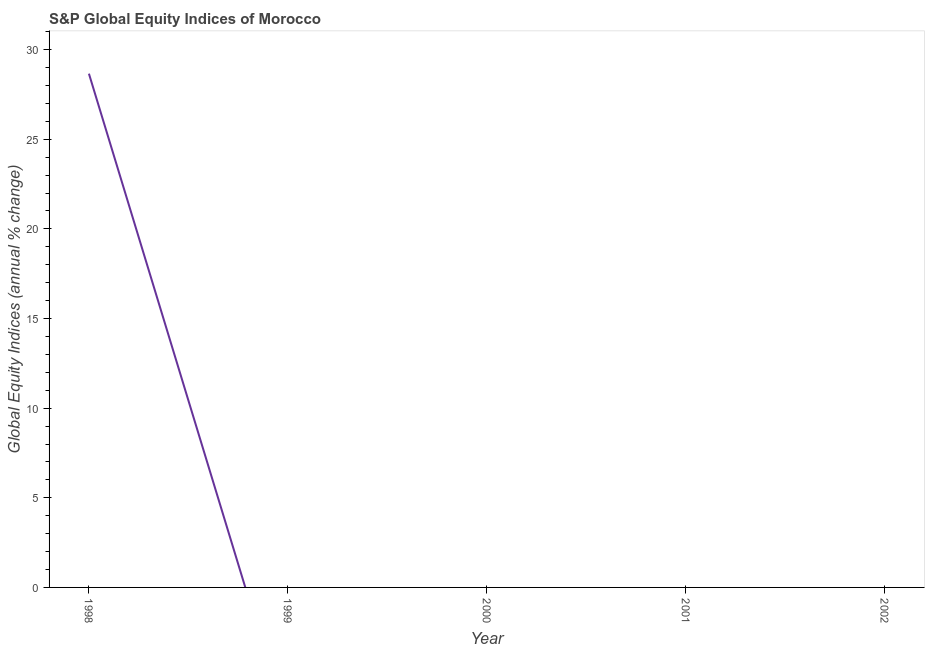Across all years, what is the maximum s&p global equity indices?
Provide a short and direct response. 28.66. In which year was the s&p global equity indices maximum?
Your answer should be compact. 1998. What is the sum of the s&p global equity indices?
Offer a terse response. 28.66. What is the average s&p global equity indices per year?
Make the answer very short. 5.73. In how many years, is the s&p global equity indices greater than 22 %?
Offer a very short reply. 1. What is the difference between the highest and the lowest s&p global equity indices?
Your response must be concise. 28.66. In how many years, is the s&p global equity indices greater than the average s&p global equity indices taken over all years?
Offer a terse response. 1. What is the difference between two consecutive major ticks on the Y-axis?
Your answer should be very brief. 5. Are the values on the major ticks of Y-axis written in scientific E-notation?
Your answer should be very brief. No. Does the graph contain any zero values?
Keep it short and to the point. Yes. Does the graph contain grids?
Offer a very short reply. No. What is the title of the graph?
Your response must be concise. S&P Global Equity Indices of Morocco. What is the label or title of the X-axis?
Offer a very short reply. Year. What is the label or title of the Y-axis?
Make the answer very short. Global Equity Indices (annual % change). What is the Global Equity Indices (annual % change) in 1998?
Provide a succinct answer. 28.66. What is the Global Equity Indices (annual % change) of 1999?
Ensure brevity in your answer.  0. What is the Global Equity Indices (annual % change) of 2000?
Ensure brevity in your answer.  0. What is the Global Equity Indices (annual % change) in 2002?
Ensure brevity in your answer.  0. 